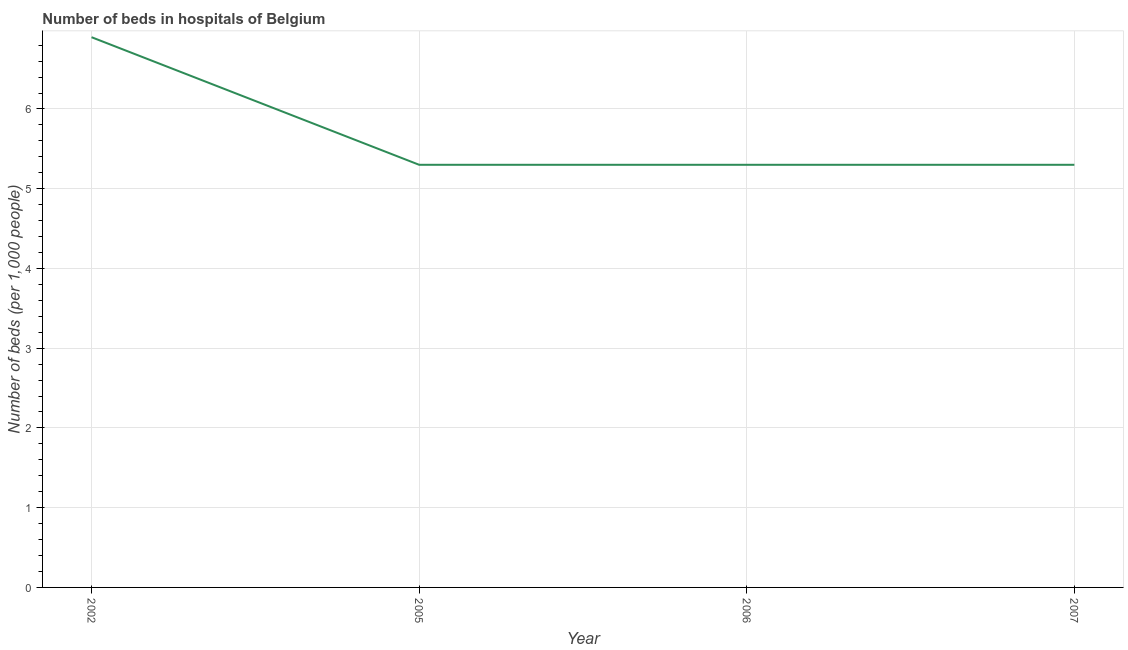What is the number of hospital beds in 2002?
Offer a very short reply. 6.9. Across all years, what is the maximum number of hospital beds?
Offer a terse response. 6.9. Across all years, what is the minimum number of hospital beds?
Your answer should be compact. 5.3. What is the sum of the number of hospital beds?
Ensure brevity in your answer.  22.8. What is the average number of hospital beds per year?
Offer a terse response. 5.7. What is the median number of hospital beds?
Offer a terse response. 5.3. Do a majority of the years between 2005 and 2007 (inclusive) have number of hospital beds greater than 2.6 %?
Provide a succinct answer. Yes. What is the ratio of the number of hospital beds in 2006 to that in 2007?
Provide a short and direct response. 1. Is the difference between the number of hospital beds in 2002 and 2007 greater than the difference between any two years?
Provide a succinct answer. Yes. What is the difference between the highest and the second highest number of hospital beds?
Offer a very short reply. 1.6. Is the sum of the number of hospital beds in 2006 and 2007 greater than the maximum number of hospital beds across all years?
Provide a short and direct response. Yes. What is the difference between the highest and the lowest number of hospital beds?
Provide a short and direct response. 1.6. In how many years, is the number of hospital beds greater than the average number of hospital beds taken over all years?
Make the answer very short. 1. Does the number of hospital beds monotonically increase over the years?
Provide a short and direct response. No. How many lines are there?
Make the answer very short. 1. How many years are there in the graph?
Your answer should be very brief. 4. What is the title of the graph?
Your answer should be very brief. Number of beds in hospitals of Belgium. What is the label or title of the X-axis?
Provide a short and direct response. Year. What is the label or title of the Y-axis?
Give a very brief answer. Number of beds (per 1,0 people). What is the Number of beds (per 1,000 people) in 2002?
Provide a succinct answer. 6.9. What is the Number of beds (per 1,000 people) of 2007?
Your answer should be very brief. 5.3. What is the difference between the Number of beds (per 1,000 people) in 2002 and 2005?
Provide a short and direct response. 1.6. What is the difference between the Number of beds (per 1,000 people) in 2002 and 2006?
Your answer should be very brief. 1.6. What is the difference between the Number of beds (per 1,000 people) in 2005 and 2007?
Your response must be concise. 0. What is the ratio of the Number of beds (per 1,000 people) in 2002 to that in 2005?
Give a very brief answer. 1.3. What is the ratio of the Number of beds (per 1,000 people) in 2002 to that in 2006?
Keep it short and to the point. 1.3. What is the ratio of the Number of beds (per 1,000 people) in 2002 to that in 2007?
Make the answer very short. 1.3. What is the ratio of the Number of beds (per 1,000 people) in 2005 to that in 2006?
Make the answer very short. 1. What is the ratio of the Number of beds (per 1,000 people) in 2005 to that in 2007?
Your response must be concise. 1. What is the ratio of the Number of beds (per 1,000 people) in 2006 to that in 2007?
Give a very brief answer. 1. 